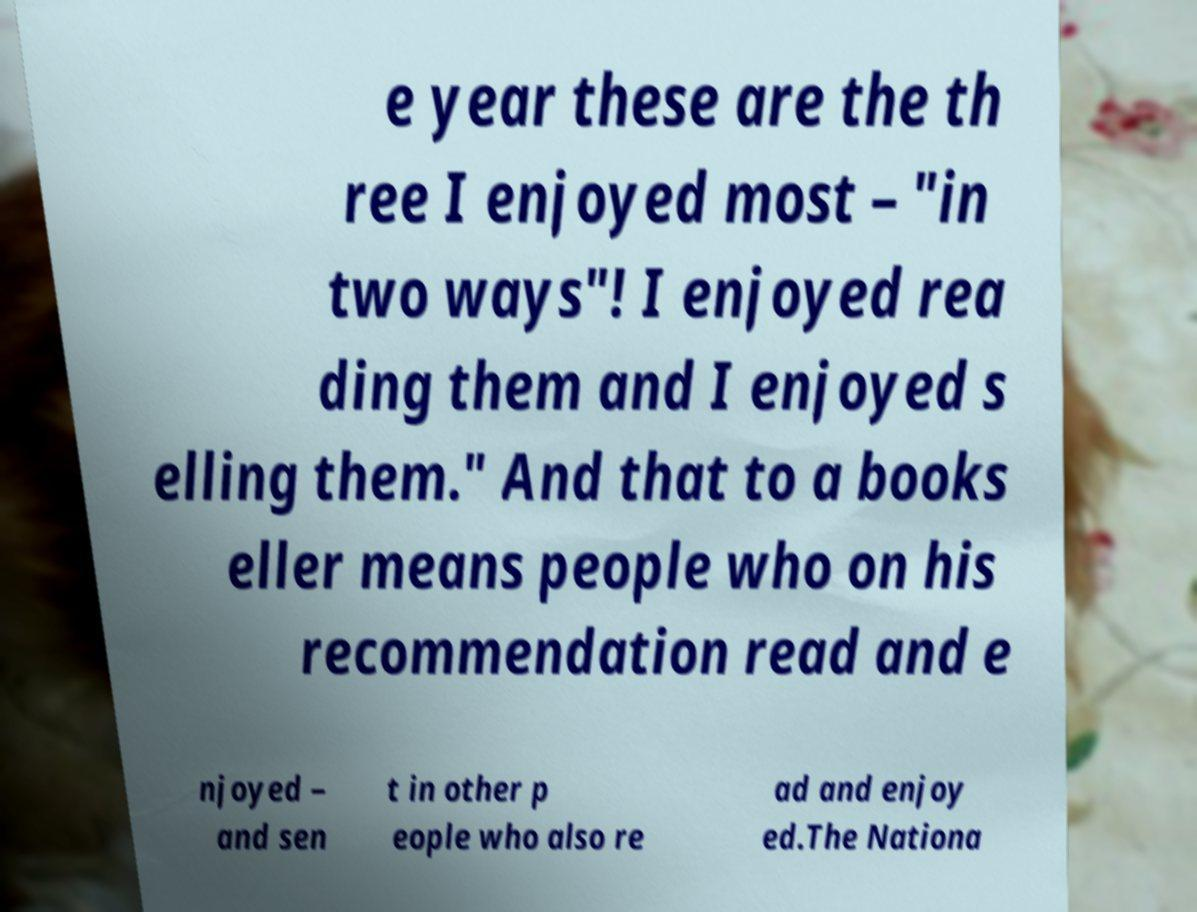Please identify and transcribe the text found in this image. e year these are the th ree I enjoyed most – "in two ways"! I enjoyed rea ding them and I enjoyed s elling them." And that to a books eller means people who on his recommendation read and e njoyed – and sen t in other p eople who also re ad and enjoy ed.The Nationa 